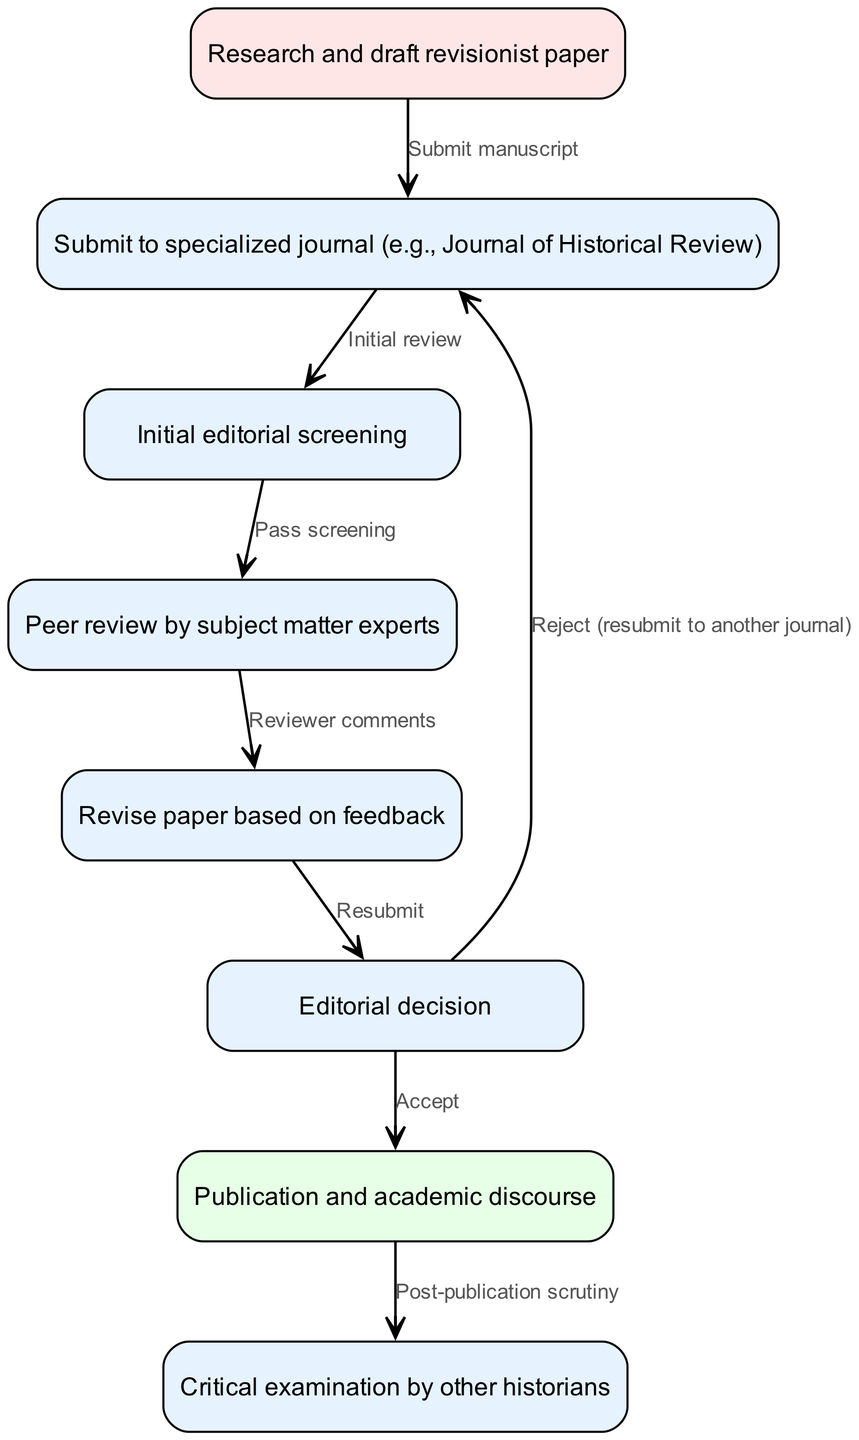What is the first step in the peer review process? The diagram indicates that the first step is "Research and draft revisionist paper," which is represented as node 1. This is the starting point of the flow.
Answer: Research and draft revisionist paper How many nodes are present in the diagram? By counting the listed nodes in the data, there are a total of eight distinct nodes, each representing a step in the process.
Answer: Eight Which node follows "Initial editorial screening"? The diagram shows an edge directing from node 3 ("Initial editorial screening") to node 4 ("Peer review by subject matter experts"), indicating that peer review follows the initial screening.
Answer: Peer review by subject matter experts What action is required after receiving reviewer comments? According to the flow chart, after "Peer review by subject matter experts" (node 4) leads to "Reviewer comments" (node 5), the required action is to "Revise paper based on feedback." This indicates that revisions are necessary.
Answer: Revise paper based on feedback What happens if the editorial decision is to reject the paper? The diagram illustrates that if the editorial decision is to reject the paper (node 6), there is an alternative route leading back to submitting to another journal (node 2). Thus, this indicates the option to "Resubmit to another journal."
Answer: Resubmit to another journal What is the final outcome of the process after publication? The final node in the process (node 8) is "Critical examination by other historians," which indicates that after publication, the paper undergoes scrutiny by peers in the field.
Answer: Critical examination by other historians Which node represents the acceptance of the paper? The diagram shows that the editorial decision (node 6) leads to publication only if it includes "Accept." This signifies the moment of acceptance in the process.
Answer: Accept What is the relationship between publication and post-publication scrutiny? The diagram details a flow from the "Publication and academic discourse" (node 7) to "Post-publication scrutiny" (node 8), establishing that once a paper is published, it enters a period of scrutiny by other historians.
Answer: Post-publication scrutiny 